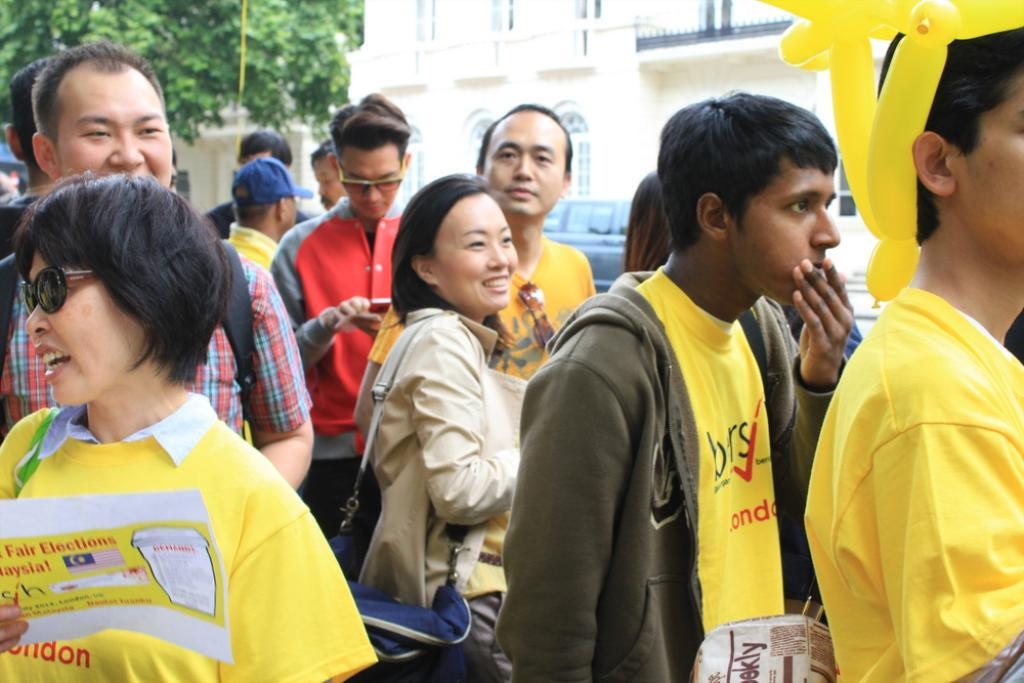How many people are in the image? There is a group of people standing in the image. What object can be seen in the image that is typically made of rubber and twisted into various shapes? There is a twisted balloon in the image. What type of object is present in the image that is used for transportation? There is a vehicle in the image. What can be seen in the background of the image that is a part of the natural environment? There is a tree in the background of the image. What can be seen in the background of the image that is a part of the built environment? There is a building in the background of the image. How much money is being exchanged between the people in the image? There is no indication of money being exchanged in the image. What type of lumber is being used to construct the building in the background? There is no lumber visible in the image, as it only shows a building in the background. 